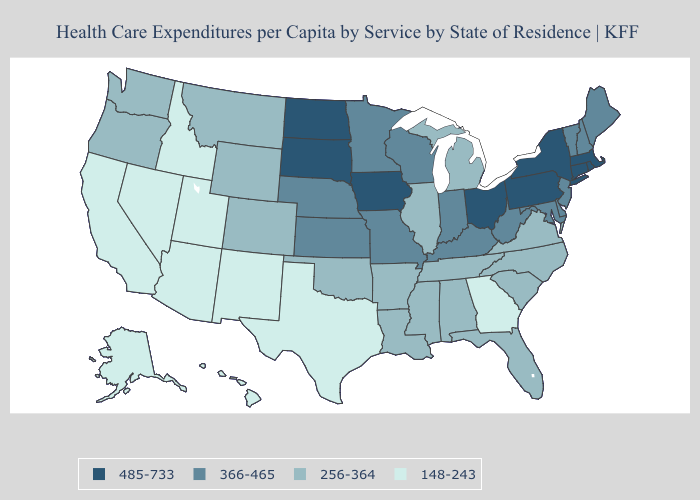Does Virginia have the highest value in the South?
Quick response, please. No. Does Maine have the highest value in the USA?
Write a very short answer. No. What is the lowest value in the USA?
Write a very short answer. 148-243. Name the states that have a value in the range 366-465?
Give a very brief answer. Delaware, Indiana, Kansas, Kentucky, Maine, Maryland, Minnesota, Missouri, Nebraska, New Hampshire, New Jersey, Vermont, West Virginia, Wisconsin. Does the first symbol in the legend represent the smallest category?
Short answer required. No. What is the value of Tennessee?
Give a very brief answer. 256-364. Name the states that have a value in the range 485-733?
Concise answer only. Connecticut, Iowa, Massachusetts, New York, North Dakota, Ohio, Pennsylvania, Rhode Island, South Dakota. What is the lowest value in states that border Utah?
Quick response, please. 148-243. Name the states that have a value in the range 148-243?
Quick response, please. Alaska, Arizona, California, Georgia, Hawaii, Idaho, Nevada, New Mexico, Texas, Utah. What is the value of Mississippi?
Answer briefly. 256-364. Name the states that have a value in the range 485-733?
Answer briefly. Connecticut, Iowa, Massachusetts, New York, North Dakota, Ohio, Pennsylvania, Rhode Island, South Dakota. Among the states that border Florida , which have the lowest value?
Short answer required. Georgia. Does Maryland have the highest value in the USA?
Quick response, please. No. Which states have the lowest value in the Northeast?
Concise answer only. Maine, New Hampshire, New Jersey, Vermont. What is the value of New Mexico?
Quick response, please. 148-243. 